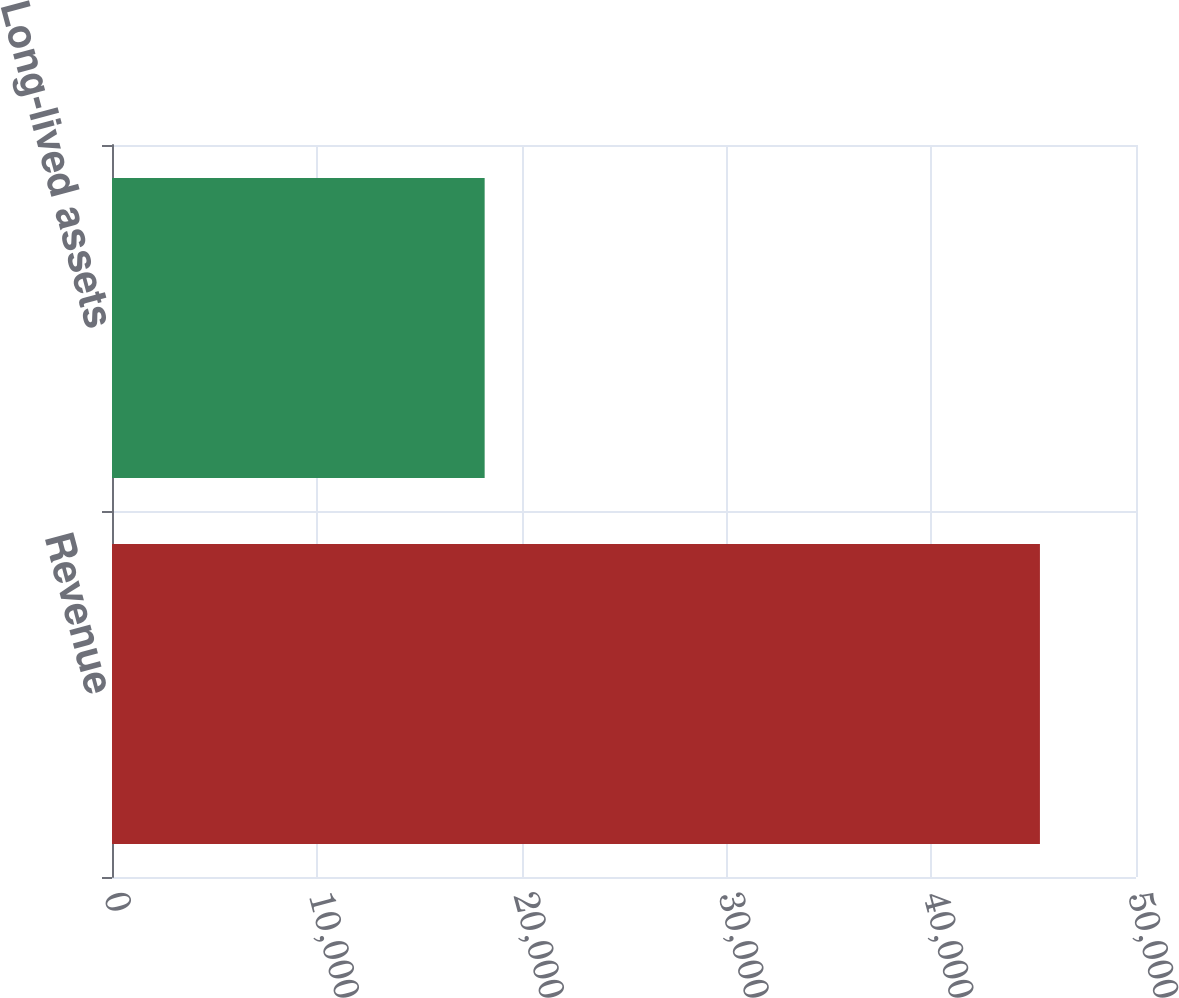Convert chart to OTSL. <chart><loc_0><loc_0><loc_500><loc_500><bar_chart><fcel>Revenue<fcel>Long-lived assets<nl><fcel>45309<fcel>18196<nl></chart> 